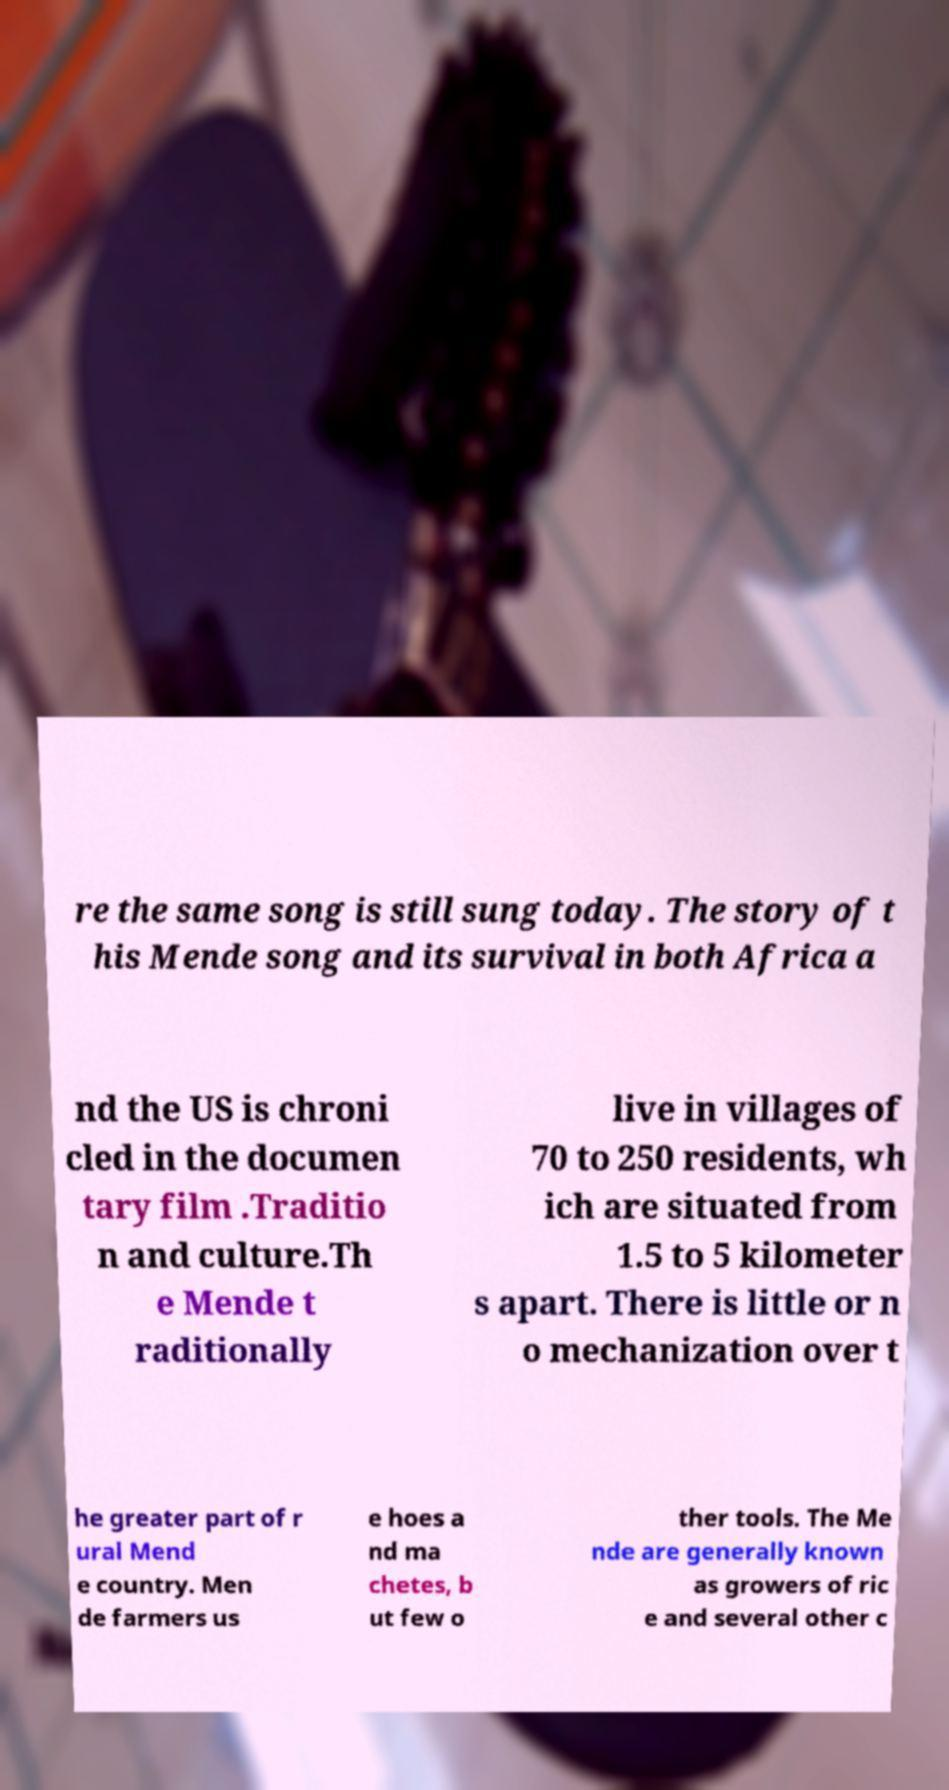Please identify and transcribe the text found in this image. re the same song is still sung today. The story of t his Mende song and its survival in both Africa a nd the US is chroni cled in the documen tary film .Traditio n and culture.Th e Mende t raditionally live in villages of 70 to 250 residents, wh ich are situated from 1.5 to 5 kilometer s apart. There is little or n o mechanization over t he greater part of r ural Mend e country. Men de farmers us e hoes a nd ma chetes, b ut few o ther tools. The Me nde are generally known as growers of ric e and several other c 